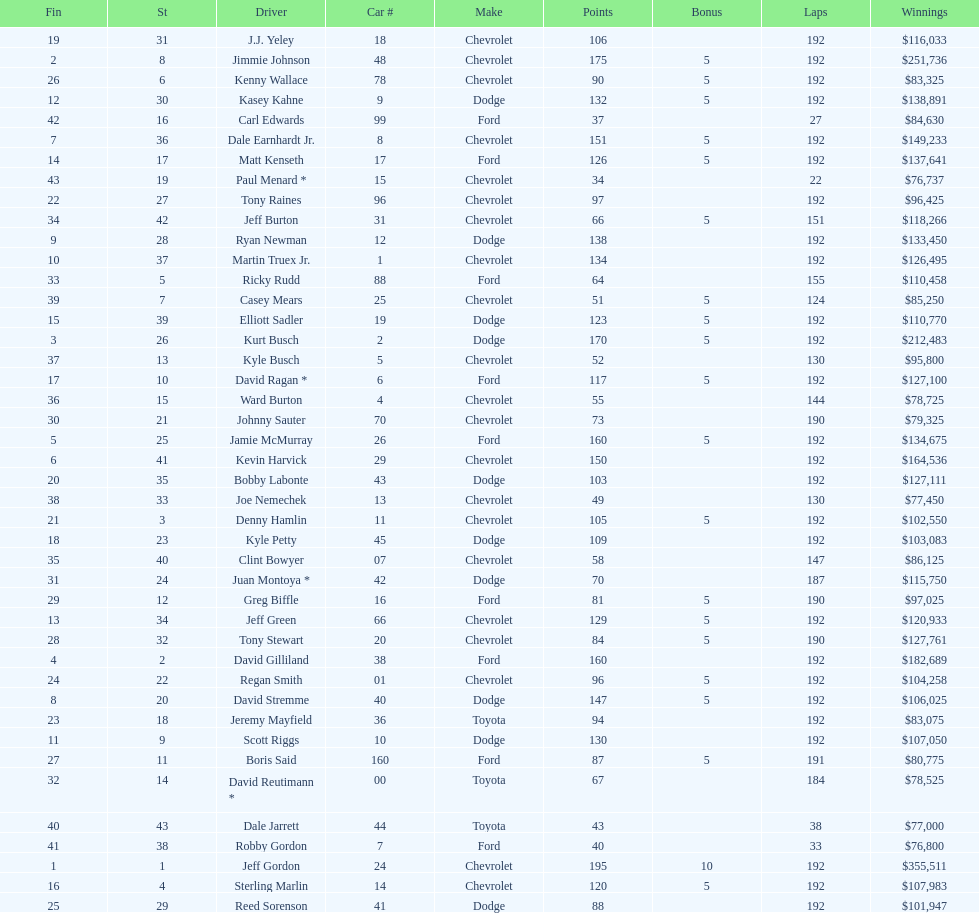Which brand had the most successive completions at the aarons 499? Chevrolet. Write the full table. {'header': ['Fin', 'St', 'Driver', 'Car #', 'Make', 'Points', 'Bonus', 'Laps', 'Winnings'], 'rows': [['19', '31', 'J.J. Yeley', '18', 'Chevrolet', '106', '', '192', '$116,033'], ['2', '8', 'Jimmie Johnson', '48', 'Chevrolet', '175', '5', '192', '$251,736'], ['26', '6', 'Kenny Wallace', '78', 'Chevrolet', '90', '5', '192', '$83,325'], ['12', '30', 'Kasey Kahne', '9', 'Dodge', '132', '5', '192', '$138,891'], ['42', '16', 'Carl Edwards', '99', 'Ford', '37', '', '27', '$84,630'], ['7', '36', 'Dale Earnhardt Jr.', '8', 'Chevrolet', '151', '5', '192', '$149,233'], ['14', '17', 'Matt Kenseth', '17', 'Ford', '126', '5', '192', '$137,641'], ['43', '19', 'Paul Menard *', '15', 'Chevrolet', '34', '', '22', '$76,737'], ['22', '27', 'Tony Raines', '96', 'Chevrolet', '97', '', '192', '$96,425'], ['34', '42', 'Jeff Burton', '31', 'Chevrolet', '66', '5', '151', '$118,266'], ['9', '28', 'Ryan Newman', '12', 'Dodge', '138', '', '192', '$133,450'], ['10', '37', 'Martin Truex Jr.', '1', 'Chevrolet', '134', '', '192', '$126,495'], ['33', '5', 'Ricky Rudd', '88', 'Ford', '64', '', '155', '$110,458'], ['39', '7', 'Casey Mears', '25', 'Chevrolet', '51', '5', '124', '$85,250'], ['15', '39', 'Elliott Sadler', '19', 'Dodge', '123', '5', '192', '$110,770'], ['3', '26', 'Kurt Busch', '2', 'Dodge', '170', '5', '192', '$212,483'], ['37', '13', 'Kyle Busch', '5', 'Chevrolet', '52', '', '130', '$95,800'], ['17', '10', 'David Ragan *', '6', 'Ford', '117', '5', '192', '$127,100'], ['36', '15', 'Ward Burton', '4', 'Chevrolet', '55', '', '144', '$78,725'], ['30', '21', 'Johnny Sauter', '70', 'Chevrolet', '73', '', '190', '$79,325'], ['5', '25', 'Jamie McMurray', '26', 'Ford', '160', '5', '192', '$134,675'], ['6', '41', 'Kevin Harvick', '29', 'Chevrolet', '150', '', '192', '$164,536'], ['20', '35', 'Bobby Labonte', '43', 'Dodge', '103', '', '192', '$127,111'], ['38', '33', 'Joe Nemechek', '13', 'Chevrolet', '49', '', '130', '$77,450'], ['21', '3', 'Denny Hamlin', '11', 'Chevrolet', '105', '5', '192', '$102,550'], ['18', '23', 'Kyle Petty', '45', 'Dodge', '109', '', '192', '$103,083'], ['35', '40', 'Clint Bowyer', '07', 'Chevrolet', '58', '', '147', '$86,125'], ['31', '24', 'Juan Montoya *', '42', 'Dodge', '70', '', '187', '$115,750'], ['29', '12', 'Greg Biffle', '16', 'Ford', '81', '5', '190', '$97,025'], ['13', '34', 'Jeff Green', '66', 'Chevrolet', '129', '5', '192', '$120,933'], ['28', '32', 'Tony Stewart', '20', 'Chevrolet', '84', '5', '190', '$127,761'], ['4', '2', 'David Gilliland', '38', 'Ford', '160', '', '192', '$182,689'], ['24', '22', 'Regan Smith', '01', 'Chevrolet', '96', '5', '192', '$104,258'], ['8', '20', 'David Stremme', '40', 'Dodge', '147', '5', '192', '$106,025'], ['23', '18', 'Jeremy Mayfield', '36', 'Toyota', '94', '', '192', '$83,075'], ['11', '9', 'Scott Riggs', '10', 'Dodge', '130', '', '192', '$107,050'], ['27', '11', 'Boris Said', '160', 'Ford', '87', '5', '191', '$80,775'], ['32', '14', 'David Reutimann *', '00', 'Toyota', '67', '', '184', '$78,525'], ['40', '43', 'Dale Jarrett', '44', 'Toyota', '43', '', '38', '$77,000'], ['41', '38', 'Robby Gordon', '7', 'Ford', '40', '', '33', '$76,800'], ['1', '1', 'Jeff Gordon', '24', 'Chevrolet', '195', '10', '192', '$355,511'], ['16', '4', 'Sterling Marlin', '14', 'Chevrolet', '120', '5', '192', '$107,983'], ['25', '29', 'Reed Sorenson', '41', 'Dodge', '88', '', '192', '$101,947']]} 